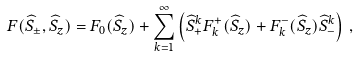<formula> <loc_0><loc_0><loc_500><loc_500>F ( \widehat { S } _ { \pm } , \widehat { S } _ { z } ) = F _ { 0 } ( \widehat { S } _ { z } ) + \sum _ { k = 1 } ^ { \infty } \left ( \widehat { S } _ { + } ^ { k } F _ { k } ^ { + } ( \widehat { S } _ { z } ) + F _ { k } ^ { - } ( \widehat { S } _ { z } ) \widehat { S } _ { - } ^ { k } \right ) \, ,</formula> 